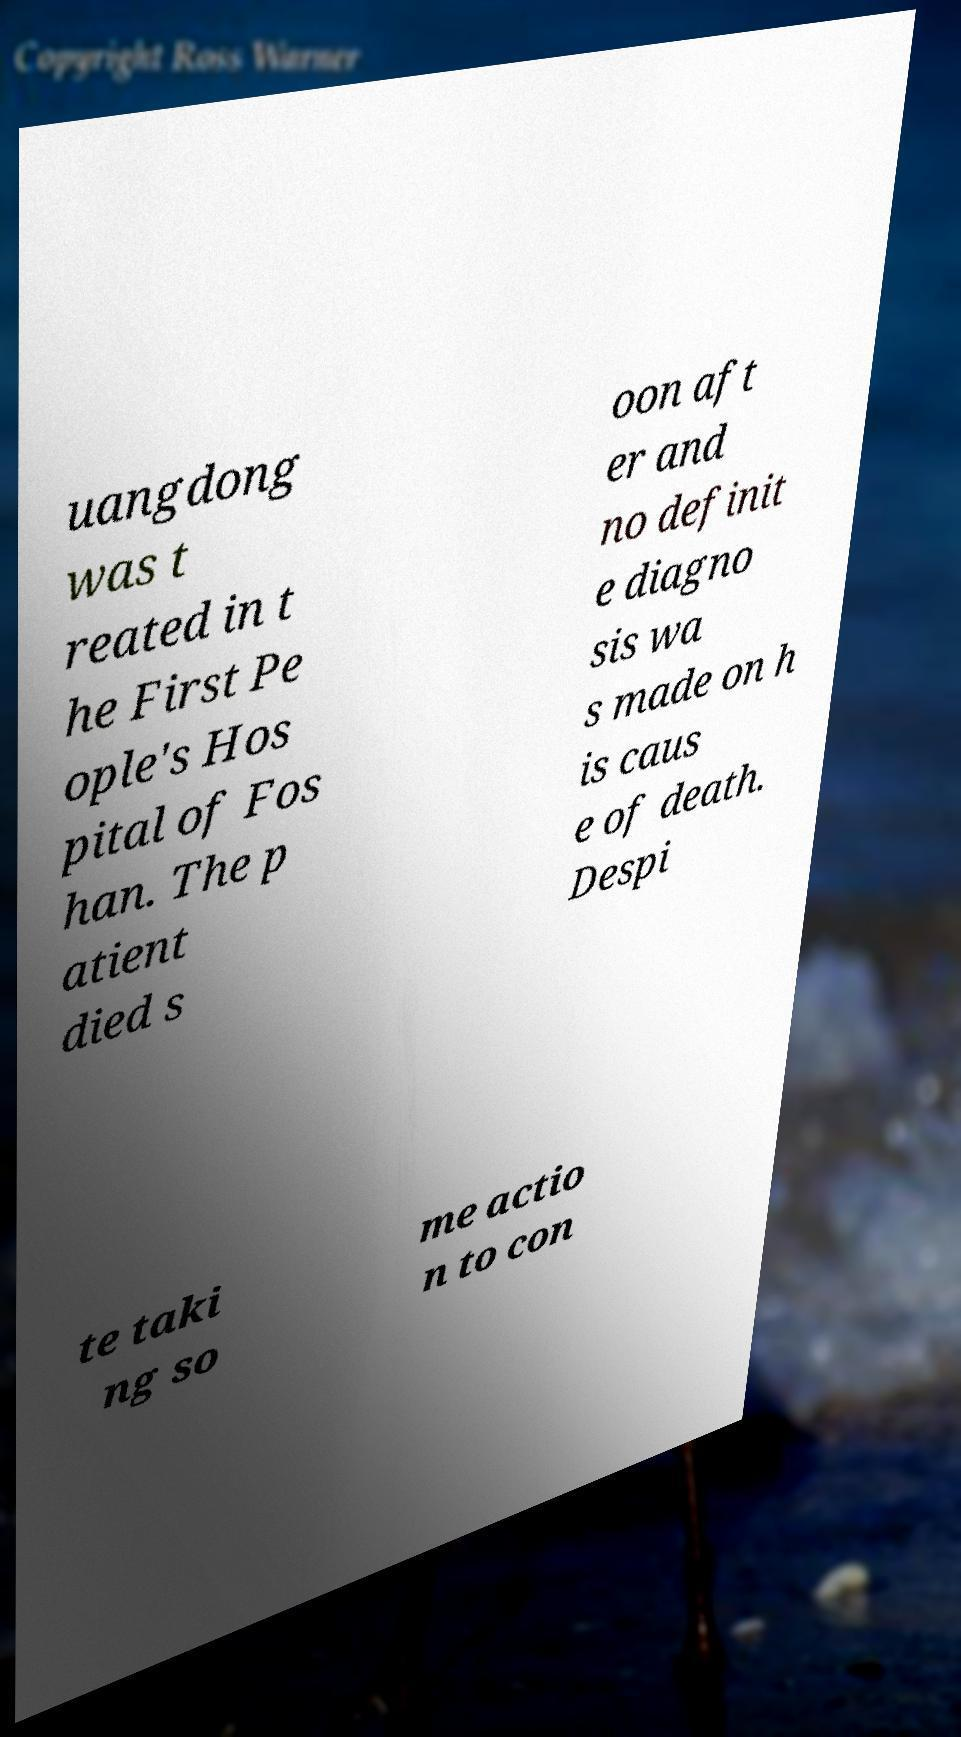I need the written content from this picture converted into text. Can you do that? uangdong was t reated in t he First Pe ople's Hos pital of Fos han. The p atient died s oon aft er and no definit e diagno sis wa s made on h is caus e of death. Despi te taki ng so me actio n to con 